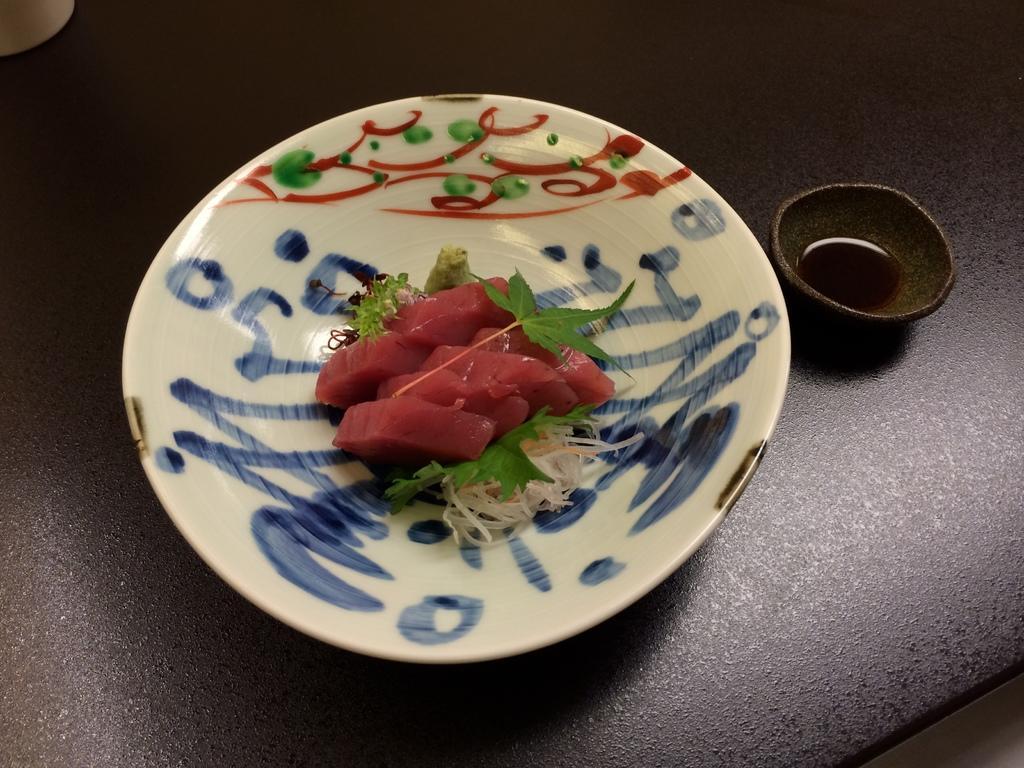In one or two sentences, can you explain what this image depicts? In this image there are food items on a plate and there are some other objects on the table. 